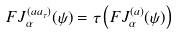<formula> <loc_0><loc_0><loc_500><loc_500>F J _ { \alpha } ^ { ( a a _ { \tau } ) } ( \psi ) = \tau \left ( F J _ { \alpha } ^ { ( a ) } ( \psi ) \right )</formula> 